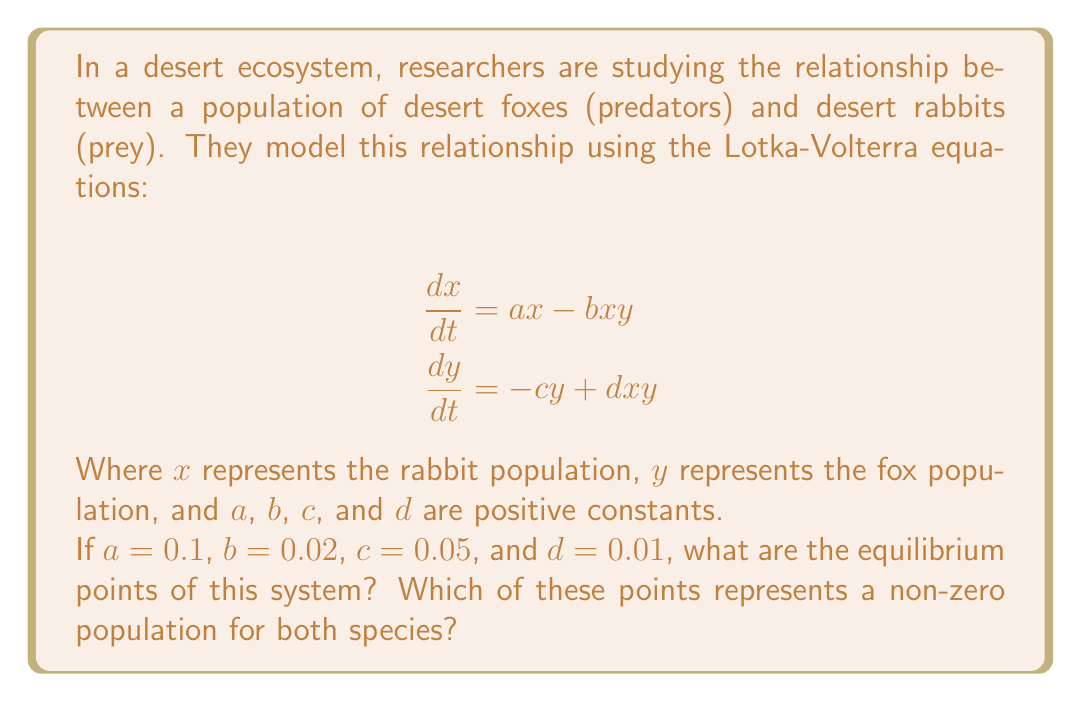Help me with this question. To find the equilibrium points, we need to set both equations equal to zero and solve for $x$ and $y$:

1) Set $\frac{dx}{dt} = 0$:
   $$0 = ax - bxy$$
   $$0 = 0.1x - 0.02xy$$

2) Set $\frac{dy}{dt} = 0$:
   $$0 = -cy + dxy$$
   $$0 = -0.05y + 0.01xy$$

3) From the first equation, we can factor out $x$:
   $$x(0.1 - 0.02y) = 0$$
   This gives us two possibilities: $x = 0$ or $0.1 - 0.02y = 0$

4) If $x = 0$, then from the second equation:
   $$0 = -0.05y$$
   This gives us $y = 0$

5) If $0.1 - 0.02y = 0$, then:
   $$y = \frac{0.1}{0.02} = 5$$
   Substituting this into the second equation:
   $$0 = -0.05(5) + 0.01x(5)$$
   $$0.25 = 0.05x$$
   $$x = 5$$

Therefore, we have two equilibrium points: $(0, 0)$ and $(5, 5)$.

The point $(5, 5)$ represents a non-zero population for both species, as both $x$ (rabbits) and $y$ (foxes) have positive values.
Answer: The equilibrium points are $(0, 0)$ and $(5, 5)$. The point $(5, 5)$ represents a non-zero population for both species. 